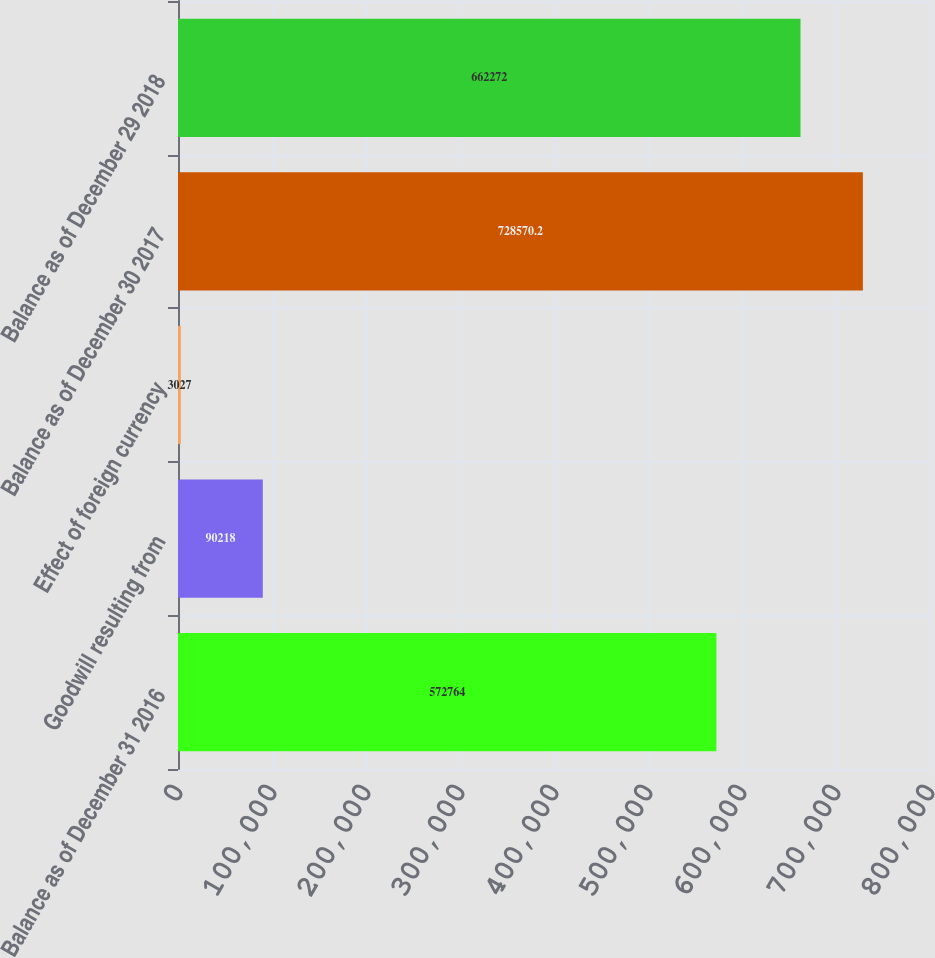Convert chart. <chart><loc_0><loc_0><loc_500><loc_500><bar_chart><fcel>Balance as of December 31 2016<fcel>Goodwill resulting from<fcel>Effect of foreign currency<fcel>Balance as of December 30 2017<fcel>Balance as of December 29 2018<nl><fcel>572764<fcel>90218<fcel>3027<fcel>728570<fcel>662272<nl></chart> 